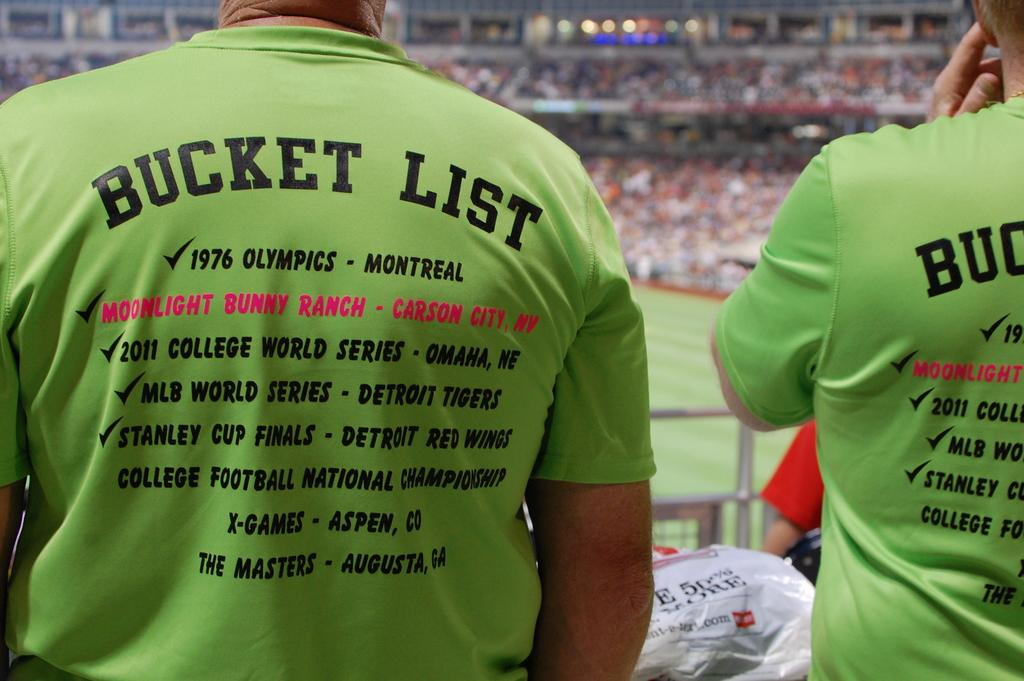What are the people in the image wearing on their upper bodies? The people in the image are wearing T-shirts with text. What can be seen in the image besides the people? There is a fence and the ground visible in the image. How is the background of the image depicted? The background of the image is blurred. What might be used to protect or cover something in the image? There is a cover in the image. How many servants are present in the image? There is no mention of servants in the image; it features people wearing T-shirts with text. What type of duck can be seen in the image? There are no ducks present in the image. 